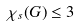<formula> <loc_0><loc_0><loc_500><loc_500>\chi _ { s } ( G ) \leq 3</formula> 